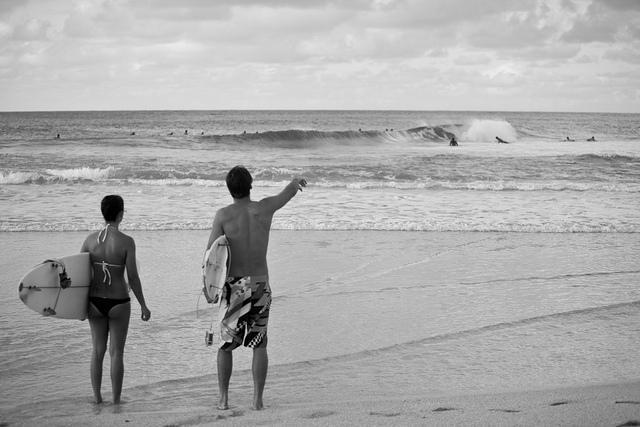How many people are there?
Give a very brief answer. 2. How many blue truck cabs are there?
Give a very brief answer. 0. 